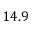Convert formula to latex. <formula><loc_0><loc_0><loc_500><loc_500>1 4 . 9</formula> 